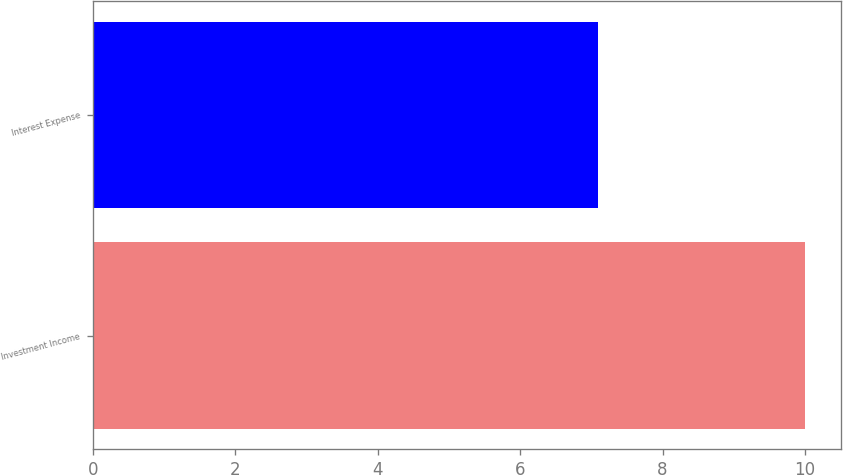Convert chart. <chart><loc_0><loc_0><loc_500><loc_500><bar_chart><fcel>Investment Income<fcel>Interest Expense<nl><fcel>10<fcel>7.1<nl></chart> 